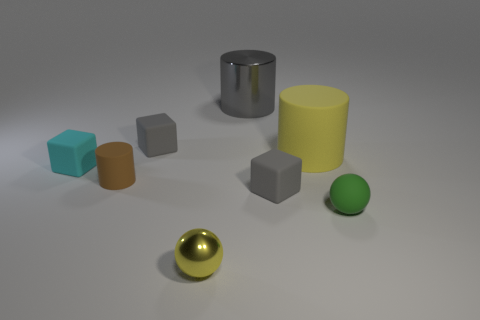Subtract all big metal cylinders. How many cylinders are left? 2 Subtract all gray cylinders. How many gray cubes are left? 2 Add 1 gray rubber things. How many objects exist? 9 Subtract all spheres. How many objects are left? 6 Subtract all red blocks. Subtract all yellow balls. How many blocks are left? 3 Add 8 large metallic cylinders. How many large metallic cylinders are left? 9 Add 2 small shiny balls. How many small shiny balls exist? 3 Subtract 1 brown cylinders. How many objects are left? 7 Subtract all large matte objects. Subtract all small cyan rubber objects. How many objects are left? 6 